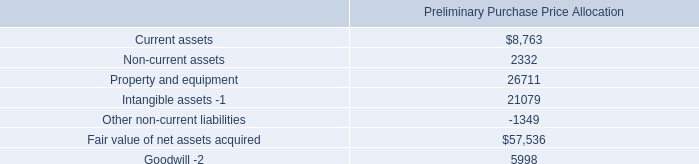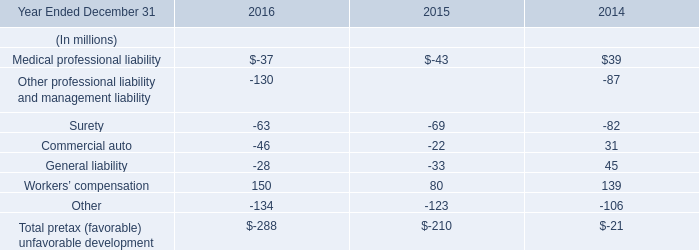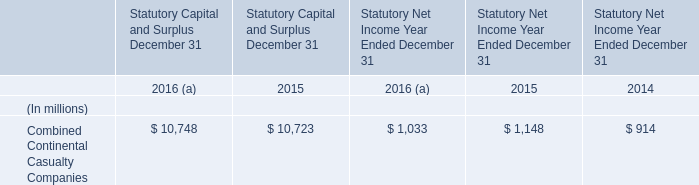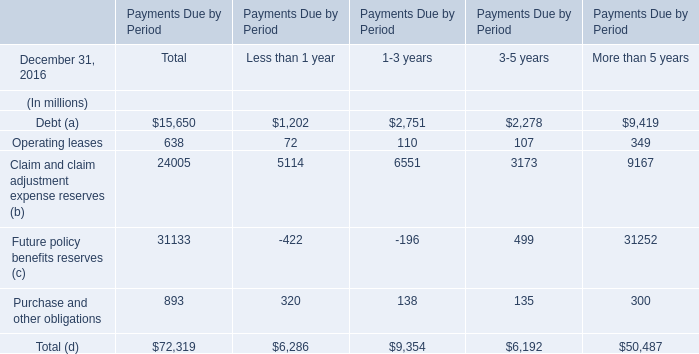for the december 14 , 2012 purchase , what was the average cost of the communications sites acquired? 
Computations: ((64.2 * 1000000) / 188)
Answer: 341489.3617. 